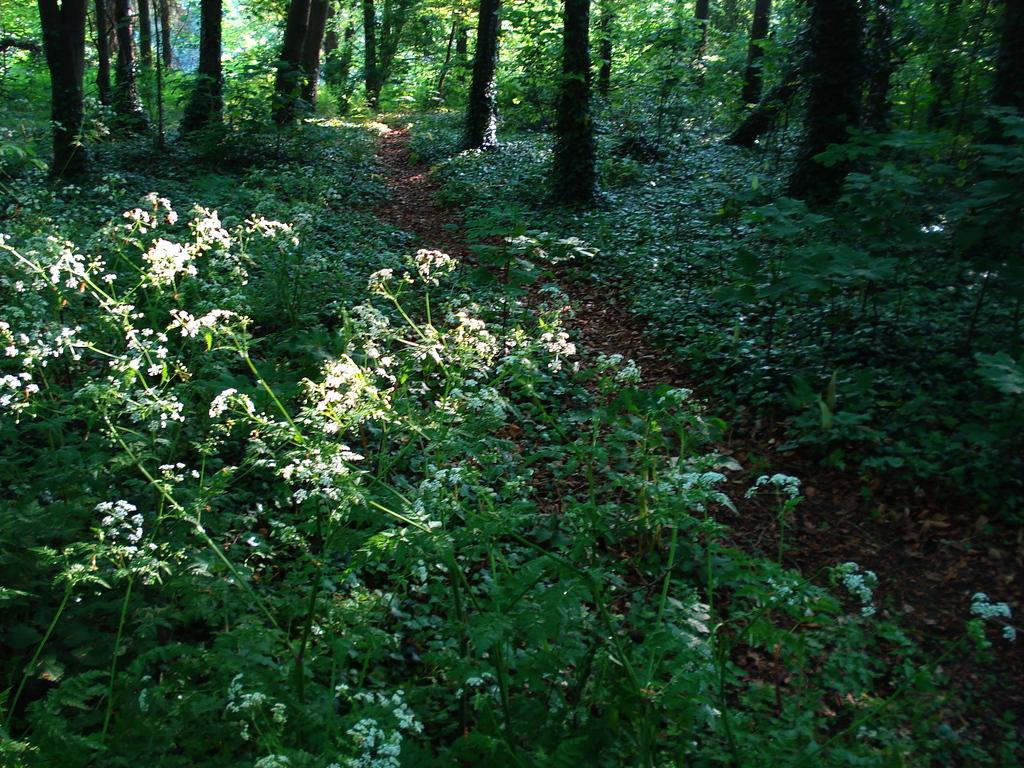What type of natural environment is depicted in the image? The image contains a forest. What are the main features of the forest? There are many trees, plants, bushes, grass, and flowers in the forest. Can you describe the vegetation in the forest? The forest contains trees, plants, bushes, and grass, with some plants having flowers. Where can we find beds in the forest? There are no beds present in the forest; it is a natural environment with vegetation. 